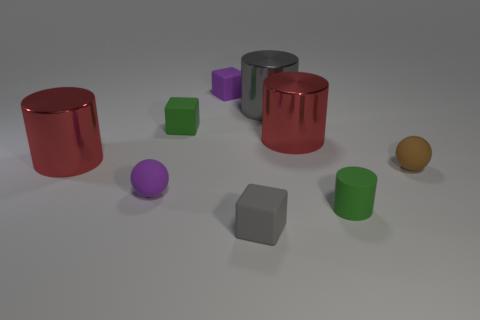Add 1 red things. How many objects exist? 10 Subtract all spheres. How many objects are left? 7 Add 8 tiny brown matte things. How many tiny brown matte things are left? 9 Add 2 tiny purple things. How many tiny purple things exist? 4 Subtract 0 green balls. How many objects are left? 9 Subtract all matte cylinders. Subtract all green blocks. How many objects are left? 7 